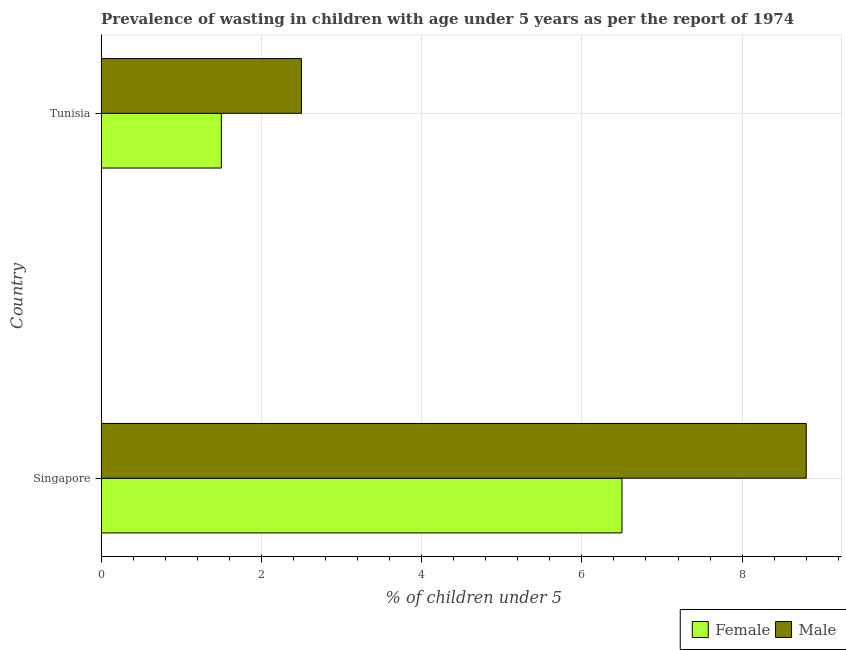How many groups of bars are there?
Your answer should be very brief. 2. Are the number of bars per tick equal to the number of legend labels?
Your response must be concise. Yes. Are the number of bars on each tick of the Y-axis equal?
Your answer should be compact. Yes. How many bars are there on the 2nd tick from the top?
Your answer should be very brief. 2. How many bars are there on the 2nd tick from the bottom?
Provide a succinct answer. 2. What is the label of the 1st group of bars from the top?
Make the answer very short. Tunisia. What is the percentage of undernourished male children in Tunisia?
Keep it short and to the point. 2.5. Across all countries, what is the minimum percentage of undernourished male children?
Provide a short and direct response. 2.5. In which country was the percentage of undernourished male children maximum?
Your answer should be compact. Singapore. In which country was the percentage of undernourished male children minimum?
Give a very brief answer. Tunisia. What is the total percentage of undernourished male children in the graph?
Ensure brevity in your answer.  11.3. What is the average percentage of undernourished male children per country?
Offer a very short reply. 5.65. In how many countries, is the percentage of undernourished male children greater than 3.6 %?
Offer a very short reply. 1. What is the ratio of the percentage of undernourished male children in Singapore to that in Tunisia?
Your answer should be compact. 3.52. What does the 1st bar from the bottom in Tunisia represents?
Your response must be concise. Female. How many bars are there?
Keep it short and to the point. 4. Are all the bars in the graph horizontal?
Ensure brevity in your answer.  Yes. Does the graph contain any zero values?
Provide a short and direct response. No. How are the legend labels stacked?
Your response must be concise. Horizontal. What is the title of the graph?
Your answer should be very brief. Prevalence of wasting in children with age under 5 years as per the report of 1974. Does "Food and tobacco" appear as one of the legend labels in the graph?
Make the answer very short. No. What is the label or title of the X-axis?
Your response must be concise.  % of children under 5. What is the label or title of the Y-axis?
Provide a succinct answer. Country. What is the  % of children under 5 in Male in Singapore?
Give a very brief answer. 8.8. What is the  % of children under 5 in Male in Tunisia?
Make the answer very short. 2.5. Across all countries, what is the maximum  % of children under 5 in Male?
Provide a succinct answer. 8.8. Across all countries, what is the minimum  % of children under 5 in Male?
Your response must be concise. 2.5. What is the difference between the  % of children under 5 in Male in Singapore and that in Tunisia?
Give a very brief answer. 6.3. What is the difference between the  % of children under 5 of Female in Singapore and the  % of children under 5 of Male in Tunisia?
Offer a very short reply. 4. What is the average  % of children under 5 in Male per country?
Your response must be concise. 5.65. What is the difference between the  % of children under 5 of Female and  % of children under 5 of Male in Singapore?
Your answer should be very brief. -2.3. What is the ratio of the  % of children under 5 of Female in Singapore to that in Tunisia?
Offer a terse response. 4.33. What is the ratio of the  % of children under 5 in Male in Singapore to that in Tunisia?
Make the answer very short. 3.52. What is the difference between the highest and the second highest  % of children under 5 in Female?
Ensure brevity in your answer.  5. What is the difference between the highest and the second highest  % of children under 5 in Male?
Your answer should be very brief. 6.3. What is the difference between the highest and the lowest  % of children under 5 in Female?
Offer a very short reply. 5. What is the difference between the highest and the lowest  % of children under 5 of Male?
Provide a short and direct response. 6.3. 